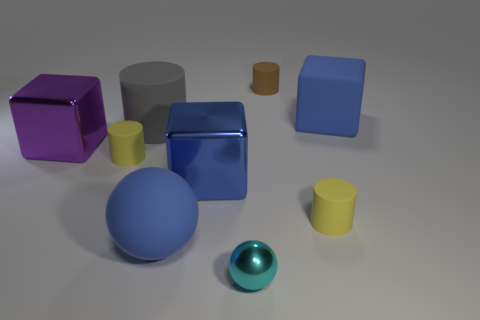What is the material of the tiny yellow thing that is to the right of the small cylinder to the left of the gray matte thing?
Ensure brevity in your answer.  Rubber. Is there another shiny sphere that has the same color as the metallic ball?
Your answer should be very brief. No. What size is the brown cylinder that is made of the same material as the gray object?
Give a very brief answer. Small. Is there anything else of the same color as the matte ball?
Keep it short and to the point. Yes. What color is the small cylinder that is on the left side of the cyan metal object?
Provide a short and direct response. Yellow. Is there a yellow cylinder on the left side of the big metal cube in front of the metallic cube left of the large matte cylinder?
Make the answer very short. Yes. Are there more tiny brown rubber cylinders behind the gray rubber cylinder than cyan cubes?
Give a very brief answer. Yes. Does the yellow matte thing on the right side of the cyan shiny object have the same shape as the gray rubber object?
Provide a short and direct response. Yes. What number of objects are either large blue blocks or large gray cylinders to the right of the large purple block?
Offer a very short reply. 3. There is a matte object that is on the right side of the large blue sphere and in front of the large blue metal thing; what is its size?
Offer a very short reply. Small. 